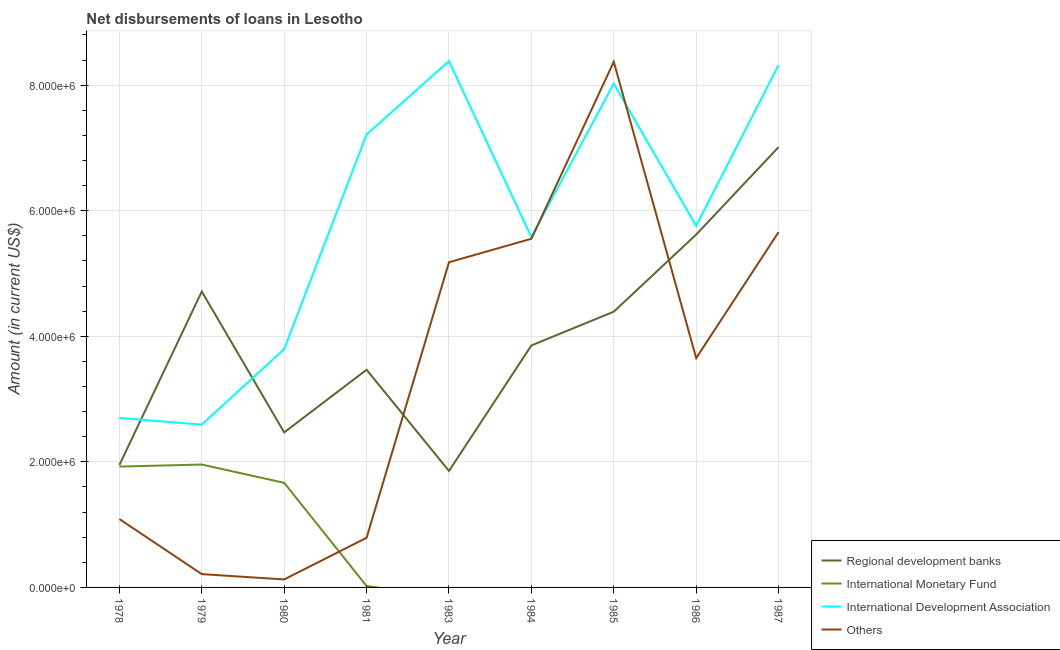What is the amount of loan disimbursed by other organisations in 1980?
Ensure brevity in your answer.  1.27e+05. Across all years, what is the maximum amount of loan disimbursed by international development association?
Give a very brief answer. 8.38e+06. Across all years, what is the minimum amount of loan disimbursed by regional development banks?
Give a very brief answer. 1.86e+06. In which year was the amount of loan disimbursed by regional development banks maximum?
Keep it short and to the point. 1987. What is the total amount of loan disimbursed by international monetary fund in the graph?
Give a very brief answer. 5.57e+06. What is the difference between the amount of loan disimbursed by other organisations in 1978 and that in 1984?
Your answer should be very brief. -4.46e+06. What is the difference between the amount of loan disimbursed by regional development banks in 1981 and the amount of loan disimbursed by other organisations in 1980?
Offer a terse response. 3.34e+06. What is the average amount of loan disimbursed by other organisations per year?
Provide a succinct answer. 3.40e+06. In the year 1980, what is the difference between the amount of loan disimbursed by international development association and amount of loan disimbursed by international monetary fund?
Provide a short and direct response. 2.13e+06. What is the ratio of the amount of loan disimbursed by international development association in 1979 to that in 1984?
Offer a very short reply. 0.46. Is the amount of loan disimbursed by regional development banks in 1979 less than that in 1986?
Provide a succinct answer. Yes. Is the difference between the amount of loan disimbursed by regional development banks in 1978 and 1979 greater than the difference between the amount of loan disimbursed by international monetary fund in 1978 and 1979?
Provide a short and direct response. No. What is the difference between the highest and the second highest amount of loan disimbursed by international development association?
Make the answer very short. 6.30e+04. What is the difference between the highest and the lowest amount of loan disimbursed by international monetary fund?
Make the answer very short. 1.96e+06. Is it the case that in every year, the sum of the amount of loan disimbursed by other organisations and amount of loan disimbursed by international development association is greater than the sum of amount of loan disimbursed by international monetary fund and amount of loan disimbursed by regional development banks?
Your response must be concise. No. Is it the case that in every year, the sum of the amount of loan disimbursed by regional development banks and amount of loan disimbursed by international monetary fund is greater than the amount of loan disimbursed by international development association?
Your response must be concise. No. Are the values on the major ticks of Y-axis written in scientific E-notation?
Offer a very short reply. Yes. Does the graph contain grids?
Your answer should be very brief. Yes. Where does the legend appear in the graph?
Make the answer very short. Bottom right. How many legend labels are there?
Your answer should be very brief. 4. How are the legend labels stacked?
Provide a short and direct response. Vertical. What is the title of the graph?
Keep it short and to the point. Net disbursements of loans in Lesotho. What is the label or title of the Y-axis?
Make the answer very short. Amount (in current US$). What is the Amount (in current US$) in Regional development banks in 1978?
Provide a succinct answer. 1.95e+06. What is the Amount (in current US$) of International Monetary Fund in 1978?
Provide a succinct answer. 1.92e+06. What is the Amount (in current US$) of International Development Association in 1978?
Offer a terse response. 2.70e+06. What is the Amount (in current US$) of Others in 1978?
Give a very brief answer. 1.09e+06. What is the Amount (in current US$) in Regional development banks in 1979?
Your response must be concise. 4.71e+06. What is the Amount (in current US$) in International Monetary Fund in 1979?
Your answer should be very brief. 1.96e+06. What is the Amount (in current US$) of International Development Association in 1979?
Provide a succinct answer. 2.59e+06. What is the Amount (in current US$) of Others in 1979?
Give a very brief answer. 2.12e+05. What is the Amount (in current US$) in Regional development banks in 1980?
Provide a short and direct response. 2.47e+06. What is the Amount (in current US$) in International Monetary Fund in 1980?
Your answer should be very brief. 1.67e+06. What is the Amount (in current US$) in International Development Association in 1980?
Your response must be concise. 3.80e+06. What is the Amount (in current US$) in Others in 1980?
Your response must be concise. 1.27e+05. What is the Amount (in current US$) of Regional development banks in 1981?
Provide a succinct answer. 3.47e+06. What is the Amount (in current US$) of International Monetary Fund in 1981?
Provide a succinct answer. 2.20e+04. What is the Amount (in current US$) in International Development Association in 1981?
Your response must be concise. 7.21e+06. What is the Amount (in current US$) in Others in 1981?
Keep it short and to the point. 7.91e+05. What is the Amount (in current US$) in Regional development banks in 1983?
Ensure brevity in your answer.  1.86e+06. What is the Amount (in current US$) in International Development Association in 1983?
Your answer should be very brief. 8.38e+06. What is the Amount (in current US$) in Others in 1983?
Offer a terse response. 5.18e+06. What is the Amount (in current US$) in Regional development banks in 1984?
Your answer should be very brief. 3.85e+06. What is the Amount (in current US$) of International Monetary Fund in 1984?
Your answer should be very brief. 0. What is the Amount (in current US$) of International Development Association in 1984?
Keep it short and to the point. 5.58e+06. What is the Amount (in current US$) in Others in 1984?
Offer a terse response. 5.55e+06. What is the Amount (in current US$) of Regional development banks in 1985?
Provide a succinct answer. 4.39e+06. What is the Amount (in current US$) in International Monetary Fund in 1985?
Offer a terse response. 0. What is the Amount (in current US$) of International Development Association in 1985?
Provide a succinct answer. 8.02e+06. What is the Amount (in current US$) of Others in 1985?
Your response must be concise. 8.37e+06. What is the Amount (in current US$) of Regional development banks in 1986?
Your answer should be compact. 5.62e+06. What is the Amount (in current US$) in International Development Association in 1986?
Keep it short and to the point. 5.76e+06. What is the Amount (in current US$) in Others in 1986?
Your answer should be very brief. 3.65e+06. What is the Amount (in current US$) of Regional development banks in 1987?
Make the answer very short. 7.01e+06. What is the Amount (in current US$) of International Development Association in 1987?
Offer a very short reply. 8.32e+06. What is the Amount (in current US$) of Others in 1987?
Give a very brief answer. 5.66e+06. Across all years, what is the maximum Amount (in current US$) of Regional development banks?
Offer a terse response. 7.01e+06. Across all years, what is the maximum Amount (in current US$) in International Monetary Fund?
Keep it short and to the point. 1.96e+06. Across all years, what is the maximum Amount (in current US$) of International Development Association?
Give a very brief answer. 8.38e+06. Across all years, what is the maximum Amount (in current US$) in Others?
Your answer should be compact. 8.37e+06. Across all years, what is the minimum Amount (in current US$) in Regional development banks?
Your answer should be very brief. 1.86e+06. Across all years, what is the minimum Amount (in current US$) in International Development Association?
Make the answer very short. 2.59e+06. Across all years, what is the minimum Amount (in current US$) of Others?
Keep it short and to the point. 1.27e+05. What is the total Amount (in current US$) of Regional development banks in the graph?
Make the answer very short. 3.53e+07. What is the total Amount (in current US$) of International Monetary Fund in the graph?
Give a very brief answer. 5.57e+06. What is the total Amount (in current US$) of International Development Association in the graph?
Your answer should be compact. 5.24e+07. What is the total Amount (in current US$) of Others in the graph?
Offer a very short reply. 3.06e+07. What is the difference between the Amount (in current US$) of Regional development banks in 1978 and that in 1979?
Offer a terse response. -2.76e+06. What is the difference between the Amount (in current US$) in International Monetary Fund in 1978 and that in 1979?
Ensure brevity in your answer.  -3.20e+04. What is the difference between the Amount (in current US$) in International Development Association in 1978 and that in 1979?
Offer a very short reply. 1.06e+05. What is the difference between the Amount (in current US$) of Others in 1978 and that in 1979?
Ensure brevity in your answer.  8.77e+05. What is the difference between the Amount (in current US$) in Regional development banks in 1978 and that in 1980?
Give a very brief answer. -5.19e+05. What is the difference between the Amount (in current US$) of International Monetary Fund in 1978 and that in 1980?
Give a very brief answer. 2.59e+05. What is the difference between the Amount (in current US$) in International Development Association in 1978 and that in 1980?
Keep it short and to the point. -1.10e+06. What is the difference between the Amount (in current US$) of Others in 1978 and that in 1980?
Give a very brief answer. 9.62e+05. What is the difference between the Amount (in current US$) of Regional development banks in 1978 and that in 1981?
Your answer should be very brief. -1.52e+06. What is the difference between the Amount (in current US$) in International Monetary Fund in 1978 and that in 1981?
Your answer should be very brief. 1.90e+06. What is the difference between the Amount (in current US$) of International Development Association in 1978 and that in 1981?
Your answer should be very brief. -4.51e+06. What is the difference between the Amount (in current US$) in Others in 1978 and that in 1981?
Make the answer very short. 2.98e+05. What is the difference between the Amount (in current US$) in Regional development banks in 1978 and that in 1983?
Your response must be concise. 9.50e+04. What is the difference between the Amount (in current US$) of International Development Association in 1978 and that in 1983?
Keep it short and to the point. -5.68e+06. What is the difference between the Amount (in current US$) in Others in 1978 and that in 1983?
Keep it short and to the point. -4.09e+06. What is the difference between the Amount (in current US$) in Regional development banks in 1978 and that in 1984?
Provide a succinct answer. -1.90e+06. What is the difference between the Amount (in current US$) of International Development Association in 1978 and that in 1984?
Make the answer very short. -2.88e+06. What is the difference between the Amount (in current US$) in Others in 1978 and that in 1984?
Provide a succinct answer. -4.46e+06. What is the difference between the Amount (in current US$) of Regional development banks in 1978 and that in 1985?
Your answer should be compact. -2.44e+06. What is the difference between the Amount (in current US$) in International Development Association in 1978 and that in 1985?
Ensure brevity in your answer.  -5.32e+06. What is the difference between the Amount (in current US$) in Others in 1978 and that in 1985?
Provide a short and direct response. -7.28e+06. What is the difference between the Amount (in current US$) of Regional development banks in 1978 and that in 1986?
Ensure brevity in your answer.  -3.67e+06. What is the difference between the Amount (in current US$) in International Development Association in 1978 and that in 1986?
Offer a terse response. -3.06e+06. What is the difference between the Amount (in current US$) in Others in 1978 and that in 1986?
Provide a short and direct response. -2.56e+06. What is the difference between the Amount (in current US$) in Regional development banks in 1978 and that in 1987?
Provide a succinct answer. -5.06e+06. What is the difference between the Amount (in current US$) in International Development Association in 1978 and that in 1987?
Offer a terse response. -5.62e+06. What is the difference between the Amount (in current US$) in Others in 1978 and that in 1987?
Offer a terse response. -4.57e+06. What is the difference between the Amount (in current US$) of Regional development banks in 1979 and that in 1980?
Your answer should be compact. 2.24e+06. What is the difference between the Amount (in current US$) of International Monetary Fund in 1979 and that in 1980?
Make the answer very short. 2.91e+05. What is the difference between the Amount (in current US$) in International Development Association in 1979 and that in 1980?
Provide a succinct answer. -1.20e+06. What is the difference between the Amount (in current US$) of Others in 1979 and that in 1980?
Make the answer very short. 8.50e+04. What is the difference between the Amount (in current US$) of Regional development banks in 1979 and that in 1981?
Your answer should be very brief. 1.25e+06. What is the difference between the Amount (in current US$) in International Monetary Fund in 1979 and that in 1981?
Provide a succinct answer. 1.94e+06. What is the difference between the Amount (in current US$) of International Development Association in 1979 and that in 1981?
Your response must be concise. -4.62e+06. What is the difference between the Amount (in current US$) of Others in 1979 and that in 1981?
Your response must be concise. -5.79e+05. What is the difference between the Amount (in current US$) in Regional development banks in 1979 and that in 1983?
Your answer should be very brief. 2.86e+06. What is the difference between the Amount (in current US$) in International Development Association in 1979 and that in 1983?
Offer a very short reply. -5.79e+06. What is the difference between the Amount (in current US$) in Others in 1979 and that in 1983?
Your answer should be very brief. -4.97e+06. What is the difference between the Amount (in current US$) in Regional development banks in 1979 and that in 1984?
Give a very brief answer. 8.59e+05. What is the difference between the Amount (in current US$) of International Development Association in 1979 and that in 1984?
Give a very brief answer. -2.99e+06. What is the difference between the Amount (in current US$) in Others in 1979 and that in 1984?
Offer a terse response. -5.34e+06. What is the difference between the Amount (in current US$) of Regional development banks in 1979 and that in 1985?
Ensure brevity in your answer.  3.21e+05. What is the difference between the Amount (in current US$) of International Development Association in 1979 and that in 1985?
Give a very brief answer. -5.43e+06. What is the difference between the Amount (in current US$) of Others in 1979 and that in 1985?
Offer a terse response. -8.16e+06. What is the difference between the Amount (in current US$) of Regional development banks in 1979 and that in 1986?
Offer a very short reply. -9.07e+05. What is the difference between the Amount (in current US$) of International Development Association in 1979 and that in 1986?
Ensure brevity in your answer.  -3.17e+06. What is the difference between the Amount (in current US$) of Others in 1979 and that in 1986?
Keep it short and to the point. -3.44e+06. What is the difference between the Amount (in current US$) in Regional development banks in 1979 and that in 1987?
Offer a terse response. -2.30e+06. What is the difference between the Amount (in current US$) in International Development Association in 1979 and that in 1987?
Your answer should be compact. -5.73e+06. What is the difference between the Amount (in current US$) of Others in 1979 and that in 1987?
Give a very brief answer. -5.45e+06. What is the difference between the Amount (in current US$) of Regional development banks in 1980 and that in 1981?
Keep it short and to the point. -9.98e+05. What is the difference between the Amount (in current US$) in International Monetary Fund in 1980 and that in 1981?
Your answer should be very brief. 1.64e+06. What is the difference between the Amount (in current US$) in International Development Association in 1980 and that in 1981?
Provide a short and direct response. -3.42e+06. What is the difference between the Amount (in current US$) in Others in 1980 and that in 1981?
Give a very brief answer. -6.64e+05. What is the difference between the Amount (in current US$) in Regional development banks in 1980 and that in 1983?
Your answer should be very brief. 6.14e+05. What is the difference between the Amount (in current US$) in International Development Association in 1980 and that in 1983?
Make the answer very short. -4.59e+06. What is the difference between the Amount (in current US$) in Others in 1980 and that in 1983?
Keep it short and to the point. -5.05e+06. What is the difference between the Amount (in current US$) in Regional development banks in 1980 and that in 1984?
Offer a very short reply. -1.38e+06. What is the difference between the Amount (in current US$) of International Development Association in 1980 and that in 1984?
Provide a short and direct response. -1.79e+06. What is the difference between the Amount (in current US$) of Others in 1980 and that in 1984?
Keep it short and to the point. -5.43e+06. What is the difference between the Amount (in current US$) of Regional development banks in 1980 and that in 1985?
Your answer should be compact. -1.92e+06. What is the difference between the Amount (in current US$) in International Development Association in 1980 and that in 1985?
Your response must be concise. -4.23e+06. What is the difference between the Amount (in current US$) of Others in 1980 and that in 1985?
Your answer should be compact. -8.24e+06. What is the difference between the Amount (in current US$) of Regional development banks in 1980 and that in 1986?
Provide a succinct answer. -3.15e+06. What is the difference between the Amount (in current US$) of International Development Association in 1980 and that in 1986?
Provide a succinct answer. -1.96e+06. What is the difference between the Amount (in current US$) of Others in 1980 and that in 1986?
Ensure brevity in your answer.  -3.52e+06. What is the difference between the Amount (in current US$) in Regional development banks in 1980 and that in 1987?
Your answer should be compact. -4.54e+06. What is the difference between the Amount (in current US$) of International Development Association in 1980 and that in 1987?
Offer a very short reply. -4.52e+06. What is the difference between the Amount (in current US$) in Others in 1980 and that in 1987?
Provide a short and direct response. -5.53e+06. What is the difference between the Amount (in current US$) in Regional development banks in 1981 and that in 1983?
Your response must be concise. 1.61e+06. What is the difference between the Amount (in current US$) in International Development Association in 1981 and that in 1983?
Your answer should be compact. -1.17e+06. What is the difference between the Amount (in current US$) in Others in 1981 and that in 1983?
Give a very brief answer. -4.39e+06. What is the difference between the Amount (in current US$) of Regional development banks in 1981 and that in 1984?
Ensure brevity in your answer.  -3.87e+05. What is the difference between the Amount (in current US$) of International Development Association in 1981 and that in 1984?
Offer a very short reply. 1.63e+06. What is the difference between the Amount (in current US$) of Others in 1981 and that in 1984?
Your answer should be compact. -4.76e+06. What is the difference between the Amount (in current US$) in Regional development banks in 1981 and that in 1985?
Your answer should be compact. -9.25e+05. What is the difference between the Amount (in current US$) in International Development Association in 1981 and that in 1985?
Offer a very short reply. -8.11e+05. What is the difference between the Amount (in current US$) of Others in 1981 and that in 1985?
Ensure brevity in your answer.  -7.58e+06. What is the difference between the Amount (in current US$) of Regional development banks in 1981 and that in 1986?
Your answer should be compact. -2.15e+06. What is the difference between the Amount (in current US$) in International Development Association in 1981 and that in 1986?
Your response must be concise. 1.45e+06. What is the difference between the Amount (in current US$) of Others in 1981 and that in 1986?
Your response must be concise. -2.86e+06. What is the difference between the Amount (in current US$) of Regional development banks in 1981 and that in 1987?
Ensure brevity in your answer.  -3.55e+06. What is the difference between the Amount (in current US$) of International Development Association in 1981 and that in 1987?
Provide a short and direct response. -1.11e+06. What is the difference between the Amount (in current US$) in Others in 1981 and that in 1987?
Make the answer very short. -4.87e+06. What is the difference between the Amount (in current US$) in Regional development banks in 1983 and that in 1984?
Give a very brief answer. -2.00e+06. What is the difference between the Amount (in current US$) of International Development Association in 1983 and that in 1984?
Offer a terse response. 2.80e+06. What is the difference between the Amount (in current US$) in Others in 1983 and that in 1984?
Offer a terse response. -3.74e+05. What is the difference between the Amount (in current US$) in Regional development banks in 1983 and that in 1985?
Ensure brevity in your answer.  -2.54e+06. What is the difference between the Amount (in current US$) of International Development Association in 1983 and that in 1985?
Your answer should be compact. 3.58e+05. What is the difference between the Amount (in current US$) of Others in 1983 and that in 1985?
Offer a terse response. -3.19e+06. What is the difference between the Amount (in current US$) of Regional development banks in 1983 and that in 1986?
Provide a succinct answer. -3.76e+06. What is the difference between the Amount (in current US$) of International Development Association in 1983 and that in 1986?
Offer a very short reply. 2.62e+06. What is the difference between the Amount (in current US$) of Others in 1983 and that in 1986?
Your answer should be very brief. 1.53e+06. What is the difference between the Amount (in current US$) in Regional development banks in 1983 and that in 1987?
Your response must be concise. -5.16e+06. What is the difference between the Amount (in current US$) of International Development Association in 1983 and that in 1987?
Offer a terse response. 6.30e+04. What is the difference between the Amount (in current US$) of Others in 1983 and that in 1987?
Keep it short and to the point. -4.80e+05. What is the difference between the Amount (in current US$) in Regional development banks in 1984 and that in 1985?
Make the answer very short. -5.38e+05. What is the difference between the Amount (in current US$) in International Development Association in 1984 and that in 1985?
Your answer should be compact. -2.44e+06. What is the difference between the Amount (in current US$) of Others in 1984 and that in 1985?
Make the answer very short. -2.82e+06. What is the difference between the Amount (in current US$) in Regional development banks in 1984 and that in 1986?
Your answer should be compact. -1.77e+06. What is the difference between the Amount (in current US$) in International Development Association in 1984 and that in 1986?
Give a very brief answer. -1.78e+05. What is the difference between the Amount (in current US$) of Others in 1984 and that in 1986?
Your response must be concise. 1.90e+06. What is the difference between the Amount (in current US$) of Regional development banks in 1984 and that in 1987?
Your answer should be compact. -3.16e+06. What is the difference between the Amount (in current US$) in International Development Association in 1984 and that in 1987?
Your answer should be compact. -2.74e+06. What is the difference between the Amount (in current US$) of Others in 1984 and that in 1987?
Offer a very short reply. -1.06e+05. What is the difference between the Amount (in current US$) in Regional development banks in 1985 and that in 1986?
Keep it short and to the point. -1.23e+06. What is the difference between the Amount (in current US$) of International Development Association in 1985 and that in 1986?
Provide a succinct answer. 2.26e+06. What is the difference between the Amount (in current US$) in Others in 1985 and that in 1986?
Offer a terse response. 4.72e+06. What is the difference between the Amount (in current US$) in Regional development banks in 1985 and that in 1987?
Provide a succinct answer. -2.62e+06. What is the difference between the Amount (in current US$) in International Development Association in 1985 and that in 1987?
Give a very brief answer. -2.95e+05. What is the difference between the Amount (in current US$) in Others in 1985 and that in 1987?
Your answer should be very brief. 2.71e+06. What is the difference between the Amount (in current US$) of Regional development banks in 1986 and that in 1987?
Provide a succinct answer. -1.39e+06. What is the difference between the Amount (in current US$) in International Development Association in 1986 and that in 1987?
Give a very brief answer. -2.56e+06. What is the difference between the Amount (in current US$) in Others in 1986 and that in 1987?
Ensure brevity in your answer.  -2.01e+06. What is the difference between the Amount (in current US$) in Regional development banks in 1978 and the Amount (in current US$) in International Monetary Fund in 1979?
Ensure brevity in your answer.  -7000. What is the difference between the Amount (in current US$) of Regional development banks in 1978 and the Amount (in current US$) of International Development Association in 1979?
Your answer should be compact. -6.43e+05. What is the difference between the Amount (in current US$) of Regional development banks in 1978 and the Amount (in current US$) of Others in 1979?
Provide a succinct answer. 1.74e+06. What is the difference between the Amount (in current US$) in International Monetary Fund in 1978 and the Amount (in current US$) in International Development Association in 1979?
Make the answer very short. -6.68e+05. What is the difference between the Amount (in current US$) of International Monetary Fund in 1978 and the Amount (in current US$) of Others in 1979?
Provide a short and direct response. 1.71e+06. What is the difference between the Amount (in current US$) of International Development Association in 1978 and the Amount (in current US$) of Others in 1979?
Make the answer very short. 2.49e+06. What is the difference between the Amount (in current US$) of Regional development banks in 1978 and the Amount (in current US$) of International Monetary Fund in 1980?
Keep it short and to the point. 2.84e+05. What is the difference between the Amount (in current US$) in Regional development banks in 1978 and the Amount (in current US$) in International Development Association in 1980?
Make the answer very short. -1.84e+06. What is the difference between the Amount (in current US$) in Regional development banks in 1978 and the Amount (in current US$) in Others in 1980?
Your response must be concise. 1.82e+06. What is the difference between the Amount (in current US$) in International Monetary Fund in 1978 and the Amount (in current US$) in International Development Association in 1980?
Provide a short and direct response. -1.87e+06. What is the difference between the Amount (in current US$) of International Monetary Fund in 1978 and the Amount (in current US$) of Others in 1980?
Provide a short and direct response. 1.80e+06. What is the difference between the Amount (in current US$) in International Development Association in 1978 and the Amount (in current US$) in Others in 1980?
Offer a very short reply. 2.57e+06. What is the difference between the Amount (in current US$) in Regional development banks in 1978 and the Amount (in current US$) in International Monetary Fund in 1981?
Your answer should be compact. 1.93e+06. What is the difference between the Amount (in current US$) of Regional development banks in 1978 and the Amount (in current US$) of International Development Association in 1981?
Offer a terse response. -5.26e+06. What is the difference between the Amount (in current US$) in Regional development banks in 1978 and the Amount (in current US$) in Others in 1981?
Make the answer very short. 1.16e+06. What is the difference between the Amount (in current US$) of International Monetary Fund in 1978 and the Amount (in current US$) of International Development Association in 1981?
Give a very brief answer. -5.29e+06. What is the difference between the Amount (in current US$) of International Monetary Fund in 1978 and the Amount (in current US$) of Others in 1981?
Keep it short and to the point. 1.13e+06. What is the difference between the Amount (in current US$) in International Development Association in 1978 and the Amount (in current US$) in Others in 1981?
Offer a very short reply. 1.91e+06. What is the difference between the Amount (in current US$) in Regional development banks in 1978 and the Amount (in current US$) in International Development Association in 1983?
Your answer should be very brief. -6.43e+06. What is the difference between the Amount (in current US$) in Regional development banks in 1978 and the Amount (in current US$) in Others in 1983?
Keep it short and to the point. -3.23e+06. What is the difference between the Amount (in current US$) of International Monetary Fund in 1978 and the Amount (in current US$) of International Development Association in 1983?
Provide a short and direct response. -6.46e+06. What is the difference between the Amount (in current US$) in International Monetary Fund in 1978 and the Amount (in current US$) in Others in 1983?
Offer a terse response. -3.25e+06. What is the difference between the Amount (in current US$) of International Development Association in 1978 and the Amount (in current US$) of Others in 1983?
Your answer should be very brief. -2.48e+06. What is the difference between the Amount (in current US$) in Regional development banks in 1978 and the Amount (in current US$) in International Development Association in 1984?
Provide a succinct answer. -3.63e+06. What is the difference between the Amount (in current US$) of Regional development banks in 1978 and the Amount (in current US$) of Others in 1984?
Offer a terse response. -3.60e+06. What is the difference between the Amount (in current US$) in International Monetary Fund in 1978 and the Amount (in current US$) in International Development Association in 1984?
Your response must be concise. -3.66e+06. What is the difference between the Amount (in current US$) of International Monetary Fund in 1978 and the Amount (in current US$) of Others in 1984?
Offer a very short reply. -3.63e+06. What is the difference between the Amount (in current US$) of International Development Association in 1978 and the Amount (in current US$) of Others in 1984?
Offer a very short reply. -2.85e+06. What is the difference between the Amount (in current US$) in Regional development banks in 1978 and the Amount (in current US$) in International Development Association in 1985?
Make the answer very short. -6.07e+06. What is the difference between the Amount (in current US$) in Regional development banks in 1978 and the Amount (in current US$) in Others in 1985?
Keep it short and to the point. -6.42e+06. What is the difference between the Amount (in current US$) of International Monetary Fund in 1978 and the Amount (in current US$) of International Development Association in 1985?
Provide a succinct answer. -6.10e+06. What is the difference between the Amount (in current US$) of International Monetary Fund in 1978 and the Amount (in current US$) of Others in 1985?
Offer a very short reply. -6.45e+06. What is the difference between the Amount (in current US$) in International Development Association in 1978 and the Amount (in current US$) in Others in 1985?
Provide a short and direct response. -5.67e+06. What is the difference between the Amount (in current US$) in Regional development banks in 1978 and the Amount (in current US$) in International Development Association in 1986?
Provide a succinct answer. -3.81e+06. What is the difference between the Amount (in current US$) of Regional development banks in 1978 and the Amount (in current US$) of Others in 1986?
Provide a short and direct response. -1.70e+06. What is the difference between the Amount (in current US$) in International Monetary Fund in 1978 and the Amount (in current US$) in International Development Association in 1986?
Keep it short and to the point. -3.83e+06. What is the difference between the Amount (in current US$) in International Monetary Fund in 1978 and the Amount (in current US$) in Others in 1986?
Give a very brief answer. -1.73e+06. What is the difference between the Amount (in current US$) of International Development Association in 1978 and the Amount (in current US$) of Others in 1986?
Offer a terse response. -9.53e+05. What is the difference between the Amount (in current US$) of Regional development banks in 1978 and the Amount (in current US$) of International Development Association in 1987?
Provide a short and direct response. -6.37e+06. What is the difference between the Amount (in current US$) in Regional development banks in 1978 and the Amount (in current US$) in Others in 1987?
Provide a succinct answer. -3.71e+06. What is the difference between the Amount (in current US$) of International Monetary Fund in 1978 and the Amount (in current US$) of International Development Association in 1987?
Ensure brevity in your answer.  -6.39e+06. What is the difference between the Amount (in current US$) in International Monetary Fund in 1978 and the Amount (in current US$) in Others in 1987?
Offer a very short reply. -3.73e+06. What is the difference between the Amount (in current US$) in International Development Association in 1978 and the Amount (in current US$) in Others in 1987?
Make the answer very short. -2.96e+06. What is the difference between the Amount (in current US$) of Regional development banks in 1979 and the Amount (in current US$) of International Monetary Fund in 1980?
Keep it short and to the point. 3.05e+06. What is the difference between the Amount (in current US$) in Regional development banks in 1979 and the Amount (in current US$) in International Development Association in 1980?
Provide a short and direct response. 9.18e+05. What is the difference between the Amount (in current US$) in Regional development banks in 1979 and the Amount (in current US$) in Others in 1980?
Offer a very short reply. 4.59e+06. What is the difference between the Amount (in current US$) of International Monetary Fund in 1979 and the Amount (in current US$) of International Development Association in 1980?
Make the answer very short. -1.84e+06. What is the difference between the Amount (in current US$) in International Monetary Fund in 1979 and the Amount (in current US$) in Others in 1980?
Provide a succinct answer. 1.83e+06. What is the difference between the Amount (in current US$) in International Development Association in 1979 and the Amount (in current US$) in Others in 1980?
Keep it short and to the point. 2.47e+06. What is the difference between the Amount (in current US$) of Regional development banks in 1979 and the Amount (in current US$) of International Monetary Fund in 1981?
Offer a very short reply. 4.69e+06. What is the difference between the Amount (in current US$) in Regional development banks in 1979 and the Amount (in current US$) in International Development Association in 1981?
Ensure brevity in your answer.  -2.50e+06. What is the difference between the Amount (in current US$) in Regional development banks in 1979 and the Amount (in current US$) in Others in 1981?
Your answer should be very brief. 3.92e+06. What is the difference between the Amount (in current US$) in International Monetary Fund in 1979 and the Amount (in current US$) in International Development Association in 1981?
Your answer should be very brief. -5.26e+06. What is the difference between the Amount (in current US$) of International Monetary Fund in 1979 and the Amount (in current US$) of Others in 1981?
Ensure brevity in your answer.  1.17e+06. What is the difference between the Amount (in current US$) in International Development Association in 1979 and the Amount (in current US$) in Others in 1981?
Make the answer very short. 1.80e+06. What is the difference between the Amount (in current US$) of Regional development banks in 1979 and the Amount (in current US$) of International Development Association in 1983?
Provide a succinct answer. -3.67e+06. What is the difference between the Amount (in current US$) in Regional development banks in 1979 and the Amount (in current US$) in Others in 1983?
Provide a succinct answer. -4.66e+05. What is the difference between the Amount (in current US$) of International Monetary Fund in 1979 and the Amount (in current US$) of International Development Association in 1983?
Offer a terse response. -6.42e+06. What is the difference between the Amount (in current US$) of International Monetary Fund in 1979 and the Amount (in current US$) of Others in 1983?
Give a very brief answer. -3.22e+06. What is the difference between the Amount (in current US$) of International Development Association in 1979 and the Amount (in current US$) of Others in 1983?
Keep it short and to the point. -2.59e+06. What is the difference between the Amount (in current US$) in Regional development banks in 1979 and the Amount (in current US$) in International Development Association in 1984?
Give a very brief answer. -8.68e+05. What is the difference between the Amount (in current US$) in Regional development banks in 1979 and the Amount (in current US$) in Others in 1984?
Keep it short and to the point. -8.40e+05. What is the difference between the Amount (in current US$) in International Monetary Fund in 1979 and the Amount (in current US$) in International Development Association in 1984?
Your response must be concise. -3.62e+06. What is the difference between the Amount (in current US$) of International Monetary Fund in 1979 and the Amount (in current US$) of Others in 1984?
Ensure brevity in your answer.  -3.60e+06. What is the difference between the Amount (in current US$) in International Development Association in 1979 and the Amount (in current US$) in Others in 1984?
Provide a short and direct response. -2.96e+06. What is the difference between the Amount (in current US$) in Regional development banks in 1979 and the Amount (in current US$) in International Development Association in 1985?
Your response must be concise. -3.31e+06. What is the difference between the Amount (in current US$) of Regional development banks in 1979 and the Amount (in current US$) of Others in 1985?
Provide a short and direct response. -3.66e+06. What is the difference between the Amount (in current US$) in International Monetary Fund in 1979 and the Amount (in current US$) in International Development Association in 1985?
Provide a succinct answer. -6.07e+06. What is the difference between the Amount (in current US$) in International Monetary Fund in 1979 and the Amount (in current US$) in Others in 1985?
Your answer should be compact. -6.42e+06. What is the difference between the Amount (in current US$) of International Development Association in 1979 and the Amount (in current US$) of Others in 1985?
Keep it short and to the point. -5.78e+06. What is the difference between the Amount (in current US$) in Regional development banks in 1979 and the Amount (in current US$) in International Development Association in 1986?
Your answer should be compact. -1.05e+06. What is the difference between the Amount (in current US$) in Regional development banks in 1979 and the Amount (in current US$) in Others in 1986?
Your answer should be very brief. 1.06e+06. What is the difference between the Amount (in current US$) in International Monetary Fund in 1979 and the Amount (in current US$) in International Development Association in 1986?
Give a very brief answer. -3.80e+06. What is the difference between the Amount (in current US$) in International Monetary Fund in 1979 and the Amount (in current US$) in Others in 1986?
Make the answer very short. -1.70e+06. What is the difference between the Amount (in current US$) of International Development Association in 1979 and the Amount (in current US$) of Others in 1986?
Your answer should be compact. -1.06e+06. What is the difference between the Amount (in current US$) in Regional development banks in 1979 and the Amount (in current US$) in International Development Association in 1987?
Provide a succinct answer. -3.61e+06. What is the difference between the Amount (in current US$) in Regional development banks in 1979 and the Amount (in current US$) in Others in 1987?
Provide a short and direct response. -9.46e+05. What is the difference between the Amount (in current US$) of International Monetary Fund in 1979 and the Amount (in current US$) of International Development Association in 1987?
Keep it short and to the point. -6.36e+06. What is the difference between the Amount (in current US$) of International Monetary Fund in 1979 and the Amount (in current US$) of Others in 1987?
Provide a short and direct response. -3.70e+06. What is the difference between the Amount (in current US$) of International Development Association in 1979 and the Amount (in current US$) of Others in 1987?
Your answer should be very brief. -3.07e+06. What is the difference between the Amount (in current US$) of Regional development banks in 1980 and the Amount (in current US$) of International Monetary Fund in 1981?
Your response must be concise. 2.45e+06. What is the difference between the Amount (in current US$) in Regional development banks in 1980 and the Amount (in current US$) in International Development Association in 1981?
Keep it short and to the point. -4.74e+06. What is the difference between the Amount (in current US$) in Regional development banks in 1980 and the Amount (in current US$) in Others in 1981?
Offer a very short reply. 1.68e+06. What is the difference between the Amount (in current US$) of International Monetary Fund in 1980 and the Amount (in current US$) of International Development Association in 1981?
Your response must be concise. -5.55e+06. What is the difference between the Amount (in current US$) in International Monetary Fund in 1980 and the Amount (in current US$) in Others in 1981?
Ensure brevity in your answer.  8.75e+05. What is the difference between the Amount (in current US$) in International Development Association in 1980 and the Amount (in current US$) in Others in 1981?
Keep it short and to the point. 3.00e+06. What is the difference between the Amount (in current US$) in Regional development banks in 1980 and the Amount (in current US$) in International Development Association in 1983?
Provide a short and direct response. -5.91e+06. What is the difference between the Amount (in current US$) in Regional development banks in 1980 and the Amount (in current US$) in Others in 1983?
Your response must be concise. -2.71e+06. What is the difference between the Amount (in current US$) of International Monetary Fund in 1980 and the Amount (in current US$) of International Development Association in 1983?
Provide a short and direct response. -6.72e+06. What is the difference between the Amount (in current US$) in International Monetary Fund in 1980 and the Amount (in current US$) in Others in 1983?
Your answer should be very brief. -3.51e+06. What is the difference between the Amount (in current US$) in International Development Association in 1980 and the Amount (in current US$) in Others in 1983?
Give a very brief answer. -1.38e+06. What is the difference between the Amount (in current US$) of Regional development banks in 1980 and the Amount (in current US$) of International Development Association in 1984?
Your answer should be compact. -3.11e+06. What is the difference between the Amount (in current US$) of Regional development banks in 1980 and the Amount (in current US$) of Others in 1984?
Offer a very short reply. -3.08e+06. What is the difference between the Amount (in current US$) of International Monetary Fund in 1980 and the Amount (in current US$) of International Development Association in 1984?
Provide a short and direct response. -3.92e+06. What is the difference between the Amount (in current US$) in International Monetary Fund in 1980 and the Amount (in current US$) in Others in 1984?
Your answer should be compact. -3.89e+06. What is the difference between the Amount (in current US$) of International Development Association in 1980 and the Amount (in current US$) of Others in 1984?
Offer a very short reply. -1.76e+06. What is the difference between the Amount (in current US$) in Regional development banks in 1980 and the Amount (in current US$) in International Development Association in 1985?
Make the answer very short. -5.56e+06. What is the difference between the Amount (in current US$) in Regional development banks in 1980 and the Amount (in current US$) in Others in 1985?
Your response must be concise. -5.90e+06. What is the difference between the Amount (in current US$) in International Monetary Fund in 1980 and the Amount (in current US$) in International Development Association in 1985?
Your response must be concise. -6.36e+06. What is the difference between the Amount (in current US$) in International Monetary Fund in 1980 and the Amount (in current US$) in Others in 1985?
Offer a terse response. -6.71e+06. What is the difference between the Amount (in current US$) in International Development Association in 1980 and the Amount (in current US$) in Others in 1985?
Offer a very short reply. -4.58e+06. What is the difference between the Amount (in current US$) in Regional development banks in 1980 and the Amount (in current US$) in International Development Association in 1986?
Provide a short and direct response. -3.29e+06. What is the difference between the Amount (in current US$) in Regional development banks in 1980 and the Amount (in current US$) in Others in 1986?
Offer a very short reply. -1.18e+06. What is the difference between the Amount (in current US$) of International Monetary Fund in 1980 and the Amount (in current US$) of International Development Association in 1986?
Your answer should be very brief. -4.09e+06. What is the difference between the Amount (in current US$) in International Monetary Fund in 1980 and the Amount (in current US$) in Others in 1986?
Ensure brevity in your answer.  -1.99e+06. What is the difference between the Amount (in current US$) of International Development Association in 1980 and the Amount (in current US$) of Others in 1986?
Give a very brief answer. 1.43e+05. What is the difference between the Amount (in current US$) of Regional development banks in 1980 and the Amount (in current US$) of International Development Association in 1987?
Offer a terse response. -5.85e+06. What is the difference between the Amount (in current US$) of Regional development banks in 1980 and the Amount (in current US$) of Others in 1987?
Ensure brevity in your answer.  -3.19e+06. What is the difference between the Amount (in current US$) in International Monetary Fund in 1980 and the Amount (in current US$) in International Development Association in 1987?
Your response must be concise. -6.65e+06. What is the difference between the Amount (in current US$) in International Monetary Fund in 1980 and the Amount (in current US$) in Others in 1987?
Your answer should be compact. -3.99e+06. What is the difference between the Amount (in current US$) of International Development Association in 1980 and the Amount (in current US$) of Others in 1987?
Provide a short and direct response. -1.86e+06. What is the difference between the Amount (in current US$) in Regional development banks in 1981 and the Amount (in current US$) in International Development Association in 1983?
Your answer should be compact. -4.92e+06. What is the difference between the Amount (in current US$) in Regional development banks in 1981 and the Amount (in current US$) in Others in 1983?
Ensure brevity in your answer.  -1.71e+06. What is the difference between the Amount (in current US$) of International Monetary Fund in 1981 and the Amount (in current US$) of International Development Association in 1983?
Your answer should be compact. -8.36e+06. What is the difference between the Amount (in current US$) in International Monetary Fund in 1981 and the Amount (in current US$) in Others in 1983?
Your answer should be very brief. -5.16e+06. What is the difference between the Amount (in current US$) in International Development Association in 1981 and the Amount (in current US$) in Others in 1983?
Ensure brevity in your answer.  2.03e+06. What is the difference between the Amount (in current US$) in Regional development banks in 1981 and the Amount (in current US$) in International Development Association in 1984?
Give a very brief answer. -2.11e+06. What is the difference between the Amount (in current US$) of Regional development banks in 1981 and the Amount (in current US$) of Others in 1984?
Give a very brief answer. -2.09e+06. What is the difference between the Amount (in current US$) in International Monetary Fund in 1981 and the Amount (in current US$) in International Development Association in 1984?
Provide a succinct answer. -5.56e+06. What is the difference between the Amount (in current US$) of International Monetary Fund in 1981 and the Amount (in current US$) of Others in 1984?
Provide a succinct answer. -5.53e+06. What is the difference between the Amount (in current US$) of International Development Association in 1981 and the Amount (in current US$) of Others in 1984?
Keep it short and to the point. 1.66e+06. What is the difference between the Amount (in current US$) of Regional development banks in 1981 and the Amount (in current US$) of International Development Association in 1985?
Make the answer very short. -4.56e+06. What is the difference between the Amount (in current US$) of Regional development banks in 1981 and the Amount (in current US$) of Others in 1985?
Provide a short and direct response. -4.90e+06. What is the difference between the Amount (in current US$) of International Monetary Fund in 1981 and the Amount (in current US$) of International Development Association in 1985?
Your answer should be compact. -8.00e+06. What is the difference between the Amount (in current US$) in International Monetary Fund in 1981 and the Amount (in current US$) in Others in 1985?
Provide a succinct answer. -8.35e+06. What is the difference between the Amount (in current US$) of International Development Association in 1981 and the Amount (in current US$) of Others in 1985?
Provide a succinct answer. -1.16e+06. What is the difference between the Amount (in current US$) of Regional development banks in 1981 and the Amount (in current US$) of International Development Association in 1986?
Provide a succinct answer. -2.29e+06. What is the difference between the Amount (in current US$) in Regional development banks in 1981 and the Amount (in current US$) in Others in 1986?
Keep it short and to the point. -1.85e+05. What is the difference between the Amount (in current US$) in International Monetary Fund in 1981 and the Amount (in current US$) in International Development Association in 1986?
Offer a very short reply. -5.74e+06. What is the difference between the Amount (in current US$) of International Monetary Fund in 1981 and the Amount (in current US$) of Others in 1986?
Ensure brevity in your answer.  -3.63e+06. What is the difference between the Amount (in current US$) in International Development Association in 1981 and the Amount (in current US$) in Others in 1986?
Keep it short and to the point. 3.56e+06. What is the difference between the Amount (in current US$) of Regional development banks in 1981 and the Amount (in current US$) of International Development Association in 1987?
Ensure brevity in your answer.  -4.85e+06. What is the difference between the Amount (in current US$) of Regional development banks in 1981 and the Amount (in current US$) of Others in 1987?
Ensure brevity in your answer.  -2.19e+06. What is the difference between the Amount (in current US$) in International Monetary Fund in 1981 and the Amount (in current US$) in International Development Association in 1987?
Your answer should be compact. -8.30e+06. What is the difference between the Amount (in current US$) of International Monetary Fund in 1981 and the Amount (in current US$) of Others in 1987?
Your answer should be compact. -5.64e+06. What is the difference between the Amount (in current US$) of International Development Association in 1981 and the Amount (in current US$) of Others in 1987?
Your response must be concise. 1.55e+06. What is the difference between the Amount (in current US$) in Regional development banks in 1983 and the Amount (in current US$) in International Development Association in 1984?
Your answer should be very brief. -3.73e+06. What is the difference between the Amount (in current US$) in Regional development banks in 1983 and the Amount (in current US$) in Others in 1984?
Your answer should be compact. -3.70e+06. What is the difference between the Amount (in current US$) in International Development Association in 1983 and the Amount (in current US$) in Others in 1984?
Your answer should be very brief. 2.83e+06. What is the difference between the Amount (in current US$) of Regional development banks in 1983 and the Amount (in current US$) of International Development Association in 1985?
Your answer should be very brief. -6.17e+06. What is the difference between the Amount (in current US$) in Regional development banks in 1983 and the Amount (in current US$) in Others in 1985?
Offer a very short reply. -6.52e+06. What is the difference between the Amount (in current US$) of Regional development banks in 1983 and the Amount (in current US$) of International Development Association in 1986?
Provide a short and direct response. -3.90e+06. What is the difference between the Amount (in current US$) in Regional development banks in 1983 and the Amount (in current US$) in Others in 1986?
Offer a very short reply. -1.80e+06. What is the difference between the Amount (in current US$) of International Development Association in 1983 and the Amount (in current US$) of Others in 1986?
Give a very brief answer. 4.73e+06. What is the difference between the Amount (in current US$) in Regional development banks in 1983 and the Amount (in current US$) in International Development Association in 1987?
Keep it short and to the point. -6.46e+06. What is the difference between the Amount (in current US$) in Regional development banks in 1983 and the Amount (in current US$) in Others in 1987?
Give a very brief answer. -3.80e+06. What is the difference between the Amount (in current US$) in International Development Association in 1983 and the Amount (in current US$) in Others in 1987?
Offer a very short reply. 2.72e+06. What is the difference between the Amount (in current US$) of Regional development banks in 1984 and the Amount (in current US$) of International Development Association in 1985?
Your response must be concise. -4.17e+06. What is the difference between the Amount (in current US$) of Regional development banks in 1984 and the Amount (in current US$) of Others in 1985?
Give a very brief answer. -4.52e+06. What is the difference between the Amount (in current US$) in International Development Association in 1984 and the Amount (in current US$) in Others in 1985?
Give a very brief answer. -2.79e+06. What is the difference between the Amount (in current US$) in Regional development banks in 1984 and the Amount (in current US$) in International Development Association in 1986?
Provide a succinct answer. -1.90e+06. What is the difference between the Amount (in current US$) in Regional development banks in 1984 and the Amount (in current US$) in Others in 1986?
Give a very brief answer. 2.02e+05. What is the difference between the Amount (in current US$) in International Development Association in 1984 and the Amount (in current US$) in Others in 1986?
Your answer should be compact. 1.93e+06. What is the difference between the Amount (in current US$) in Regional development banks in 1984 and the Amount (in current US$) in International Development Association in 1987?
Make the answer very short. -4.46e+06. What is the difference between the Amount (in current US$) of Regional development banks in 1984 and the Amount (in current US$) of Others in 1987?
Provide a succinct answer. -1.80e+06. What is the difference between the Amount (in current US$) of International Development Association in 1984 and the Amount (in current US$) of Others in 1987?
Your answer should be very brief. -7.80e+04. What is the difference between the Amount (in current US$) in Regional development banks in 1985 and the Amount (in current US$) in International Development Association in 1986?
Give a very brief answer. -1.37e+06. What is the difference between the Amount (in current US$) of Regional development banks in 1985 and the Amount (in current US$) of Others in 1986?
Ensure brevity in your answer.  7.40e+05. What is the difference between the Amount (in current US$) of International Development Association in 1985 and the Amount (in current US$) of Others in 1986?
Provide a succinct answer. 4.37e+06. What is the difference between the Amount (in current US$) in Regional development banks in 1985 and the Amount (in current US$) in International Development Association in 1987?
Provide a succinct answer. -3.93e+06. What is the difference between the Amount (in current US$) in Regional development banks in 1985 and the Amount (in current US$) in Others in 1987?
Provide a succinct answer. -1.27e+06. What is the difference between the Amount (in current US$) of International Development Association in 1985 and the Amount (in current US$) of Others in 1987?
Keep it short and to the point. 2.36e+06. What is the difference between the Amount (in current US$) in Regional development banks in 1986 and the Amount (in current US$) in International Development Association in 1987?
Make the answer very short. -2.70e+06. What is the difference between the Amount (in current US$) in Regional development banks in 1986 and the Amount (in current US$) in Others in 1987?
Provide a succinct answer. -3.90e+04. What is the average Amount (in current US$) in Regional development banks per year?
Your answer should be compact. 3.93e+06. What is the average Amount (in current US$) of International Monetary Fund per year?
Make the answer very short. 6.19e+05. What is the average Amount (in current US$) in International Development Association per year?
Provide a short and direct response. 5.82e+06. What is the average Amount (in current US$) of Others per year?
Your answer should be very brief. 3.40e+06. In the year 1978, what is the difference between the Amount (in current US$) of Regional development banks and Amount (in current US$) of International Monetary Fund?
Offer a terse response. 2.50e+04. In the year 1978, what is the difference between the Amount (in current US$) of Regional development banks and Amount (in current US$) of International Development Association?
Keep it short and to the point. -7.49e+05. In the year 1978, what is the difference between the Amount (in current US$) in Regional development banks and Amount (in current US$) in Others?
Your response must be concise. 8.61e+05. In the year 1978, what is the difference between the Amount (in current US$) of International Monetary Fund and Amount (in current US$) of International Development Association?
Your answer should be very brief. -7.74e+05. In the year 1978, what is the difference between the Amount (in current US$) in International Monetary Fund and Amount (in current US$) in Others?
Offer a very short reply. 8.36e+05. In the year 1978, what is the difference between the Amount (in current US$) in International Development Association and Amount (in current US$) in Others?
Your response must be concise. 1.61e+06. In the year 1979, what is the difference between the Amount (in current US$) in Regional development banks and Amount (in current US$) in International Monetary Fund?
Give a very brief answer. 2.76e+06. In the year 1979, what is the difference between the Amount (in current US$) of Regional development banks and Amount (in current US$) of International Development Association?
Ensure brevity in your answer.  2.12e+06. In the year 1979, what is the difference between the Amount (in current US$) of Regional development banks and Amount (in current US$) of Others?
Offer a terse response. 4.50e+06. In the year 1979, what is the difference between the Amount (in current US$) in International Monetary Fund and Amount (in current US$) in International Development Association?
Offer a terse response. -6.36e+05. In the year 1979, what is the difference between the Amount (in current US$) of International Monetary Fund and Amount (in current US$) of Others?
Make the answer very short. 1.74e+06. In the year 1979, what is the difference between the Amount (in current US$) of International Development Association and Amount (in current US$) of Others?
Your response must be concise. 2.38e+06. In the year 1980, what is the difference between the Amount (in current US$) in Regional development banks and Amount (in current US$) in International Monetary Fund?
Ensure brevity in your answer.  8.03e+05. In the year 1980, what is the difference between the Amount (in current US$) in Regional development banks and Amount (in current US$) in International Development Association?
Provide a succinct answer. -1.33e+06. In the year 1980, what is the difference between the Amount (in current US$) of Regional development banks and Amount (in current US$) of Others?
Ensure brevity in your answer.  2.34e+06. In the year 1980, what is the difference between the Amount (in current US$) of International Monetary Fund and Amount (in current US$) of International Development Association?
Offer a terse response. -2.13e+06. In the year 1980, what is the difference between the Amount (in current US$) of International Monetary Fund and Amount (in current US$) of Others?
Offer a very short reply. 1.54e+06. In the year 1980, what is the difference between the Amount (in current US$) of International Development Association and Amount (in current US$) of Others?
Give a very brief answer. 3.67e+06. In the year 1981, what is the difference between the Amount (in current US$) in Regional development banks and Amount (in current US$) in International Monetary Fund?
Give a very brief answer. 3.44e+06. In the year 1981, what is the difference between the Amount (in current US$) in Regional development banks and Amount (in current US$) in International Development Association?
Keep it short and to the point. -3.75e+06. In the year 1981, what is the difference between the Amount (in current US$) in Regional development banks and Amount (in current US$) in Others?
Give a very brief answer. 2.68e+06. In the year 1981, what is the difference between the Amount (in current US$) of International Monetary Fund and Amount (in current US$) of International Development Association?
Ensure brevity in your answer.  -7.19e+06. In the year 1981, what is the difference between the Amount (in current US$) of International Monetary Fund and Amount (in current US$) of Others?
Give a very brief answer. -7.69e+05. In the year 1981, what is the difference between the Amount (in current US$) of International Development Association and Amount (in current US$) of Others?
Ensure brevity in your answer.  6.42e+06. In the year 1983, what is the difference between the Amount (in current US$) of Regional development banks and Amount (in current US$) of International Development Association?
Make the answer very short. -6.53e+06. In the year 1983, what is the difference between the Amount (in current US$) of Regional development banks and Amount (in current US$) of Others?
Offer a very short reply. -3.32e+06. In the year 1983, what is the difference between the Amount (in current US$) of International Development Association and Amount (in current US$) of Others?
Your answer should be compact. 3.20e+06. In the year 1984, what is the difference between the Amount (in current US$) in Regional development banks and Amount (in current US$) in International Development Association?
Your answer should be compact. -1.73e+06. In the year 1984, what is the difference between the Amount (in current US$) of Regional development banks and Amount (in current US$) of Others?
Provide a succinct answer. -1.70e+06. In the year 1984, what is the difference between the Amount (in current US$) in International Development Association and Amount (in current US$) in Others?
Offer a very short reply. 2.80e+04. In the year 1985, what is the difference between the Amount (in current US$) of Regional development banks and Amount (in current US$) of International Development Association?
Your answer should be very brief. -3.63e+06. In the year 1985, what is the difference between the Amount (in current US$) in Regional development banks and Amount (in current US$) in Others?
Make the answer very short. -3.98e+06. In the year 1985, what is the difference between the Amount (in current US$) in International Development Association and Amount (in current US$) in Others?
Offer a terse response. -3.48e+05. In the year 1986, what is the difference between the Amount (in current US$) of Regional development banks and Amount (in current US$) of International Development Association?
Your response must be concise. -1.39e+05. In the year 1986, what is the difference between the Amount (in current US$) in Regional development banks and Amount (in current US$) in Others?
Offer a very short reply. 1.97e+06. In the year 1986, what is the difference between the Amount (in current US$) in International Development Association and Amount (in current US$) in Others?
Make the answer very short. 2.11e+06. In the year 1987, what is the difference between the Amount (in current US$) of Regional development banks and Amount (in current US$) of International Development Association?
Offer a very short reply. -1.31e+06. In the year 1987, what is the difference between the Amount (in current US$) of Regional development banks and Amount (in current US$) of Others?
Offer a terse response. 1.35e+06. In the year 1987, what is the difference between the Amount (in current US$) of International Development Association and Amount (in current US$) of Others?
Offer a very short reply. 2.66e+06. What is the ratio of the Amount (in current US$) of Regional development banks in 1978 to that in 1979?
Make the answer very short. 0.41. What is the ratio of the Amount (in current US$) in International Monetary Fund in 1978 to that in 1979?
Ensure brevity in your answer.  0.98. What is the ratio of the Amount (in current US$) of International Development Association in 1978 to that in 1979?
Your answer should be very brief. 1.04. What is the ratio of the Amount (in current US$) in Others in 1978 to that in 1979?
Give a very brief answer. 5.14. What is the ratio of the Amount (in current US$) in Regional development banks in 1978 to that in 1980?
Your answer should be very brief. 0.79. What is the ratio of the Amount (in current US$) of International Monetary Fund in 1978 to that in 1980?
Give a very brief answer. 1.16. What is the ratio of the Amount (in current US$) of International Development Association in 1978 to that in 1980?
Your answer should be very brief. 0.71. What is the ratio of the Amount (in current US$) in Others in 1978 to that in 1980?
Make the answer very short. 8.57. What is the ratio of the Amount (in current US$) of Regional development banks in 1978 to that in 1981?
Ensure brevity in your answer.  0.56. What is the ratio of the Amount (in current US$) in International Monetary Fund in 1978 to that in 1981?
Your response must be concise. 87.5. What is the ratio of the Amount (in current US$) in International Development Association in 1978 to that in 1981?
Keep it short and to the point. 0.37. What is the ratio of the Amount (in current US$) in Others in 1978 to that in 1981?
Offer a terse response. 1.38. What is the ratio of the Amount (in current US$) in Regional development banks in 1978 to that in 1983?
Keep it short and to the point. 1.05. What is the ratio of the Amount (in current US$) of International Development Association in 1978 to that in 1983?
Ensure brevity in your answer.  0.32. What is the ratio of the Amount (in current US$) in Others in 1978 to that in 1983?
Give a very brief answer. 0.21. What is the ratio of the Amount (in current US$) of Regional development banks in 1978 to that in 1984?
Offer a very short reply. 0.51. What is the ratio of the Amount (in current US$) in International Development Association in 1978 to that in 1984?
Provide a short and direct response. 0.48. What is the ratio of the Amount (in current US$) in Others in 1978 to that in 1984?
Keep it short and to the point. 0.2. What is the ratio of the Amount (in current US$) in Regional development banks in 1978 to that in 1985?
Provide a succinct answer. 0.44. What is the ratio of the Amount (in current US$) of International Development Association in 1978 to that in 1985?
Provide a succinct answer. 0.34. What is the ratio of the Amount (in current US$) in Others in 1978 to that in 1985?
Your answer should be compact. 0.13. What is the ratio of the Amount (in current US$) in Regional development banks in 1978 to that in 1986?
Your answer should be compact. 0.35. What is the ratio of the Amount (in current US$) of International Development Association in 1978 to that in 1986?
Your answer should be very brief. 0.47. What is the ratio of the Amount (in current US$) in Others in 1978 to that in 1986?
Your response must be concise. 0.3. What is the ratio of the Amount (in current US$) in Regional development banks in 1978 to that in 1987?
Offer a very short reply. 0.28. What is the ratio of the Amount (in current US$) in International Development Association in 1978 to that in 1987?
Keep it short and to the point. 0.32. What is the ratio of the Amount (in current US$) of Others in 1978 to that in 1987?
Provide a short and direct response. 0.19. What is the ratio of the Amount (in current US$) of Regional development banks in 1979 to that in 1980?
Provide a succinct answer. 1.91. What is the ratio of the Amount (in current US$) in International Monetary Fund in 1979 to that in 1980?
Offer a terse response. 1.17. What is the ratio of the Amount (in current US$) of International Development Association in 1979 to that in 1980?
Provide a succinct answer. 0.68. What is the ratio of the Amount (in current US$) in Others in 1979 to that in 1980?
Your answer should be very brief. 1.67. What is the ratio of the Amount (in current US$) in Regional development banks in 1979 to that in 1981?
Keep it short and to the point. 1.36. What is the ratio of the Amount (in current US$) of International Monetary Fund in 1979 to that in 1981?
Provide a short and direct response. 88.95. What is the ratio of the Amount (in current US$) in International Development Association in 1979 to that in 1981?
Provide a short and direct response. 0.36. What is the ratio of the Amount (in current US$) of Others in 1979 to that in 1981?
Give a very brief answer. 0.27. What is the ratio of the Amount (in current US$) in Regional development banks in 1979 to that in 1983?
Keep it short and to the point. 2.54. What is the ratio of the Amount (in current US$) of International Development Association in 1979 to that in 1983?
Give a very brief answer. 0.31. What is the ratio of the Amount (in current US$) in Others in 1979 to that in 1983?
Your response must be concise. 0.04. What is the ratio of the Amount (in current US$) in Regional development banks in 1979 to that in 1984?
Offer a terse response. 1.22. What is the ratio of the Amount (in current US$) in International Development Association in 1979 to that in 1984?
Ensure brevity in your answer.  0.46. What is the ratio of the Amount (in current US$) of Others in 1979 to that in 1984?
Offer a very short reply. 0.04. What is the ratio of the Amount (in current US$) of Regional development banks in 1979 to that in 1985?
Make the answer very short. 1.07. What is the ratio of the Amount (in current US$) of International Development Association in 1979 to that in 1985?
Your answer should be very brief. 0.32. What is the ratio of the Amount (in current US$) of Others in 1979 to that in 1985?
Keep it short and to the point. 0.03. What is the ratio of the Amount (in current US$) of Regional development banks in 1979 to that in 1986?
Offer a very short reply. 0.84. What is the ratio of the Amount (in current US$) in International Development Association in 1979 to that in 1986?
Your answer should be very brief. 0.45. What is the ratio of the Amount (in current US$) in Others in 1979 to that in 1986?
Make the answer very short. 0.06. What is the ratio of the Amount (in current US$) of Regional development banks in 1979 to that in 1987?
Provide a short and direct response. 0.67. What is the ratio of the Amount (in current US$) of International Development Association in 1979 to that in 1987?
Your response must be concise. 0.31. What is the ratio of the Amount (in current US$) in Others in 1979 to that in 1987?
Offer a very short reply. 0.04. What is the ratio of the Amount (in current US$) in Regional development banks in 1980 to that in 1981?
Your response must be concise. 0.71. What is the ratio of the Amount (in current US$) in International Monetary Fund in 1980 to that in 1981?
Offer a terse response. 75.73. What is the ratio of the Amount (in current US$) in International Development Association in 1980 to that in 1981?
Make the answer very short. 0.53. What is the ratio of the Amount (in current US$) in Others in 1980 to that in 1981?
Keep it short and to the point. 0.16. What is the ratio of the Amount (in current US$) of Regional development banks in 1980 to that in 1983?
Keep it short and to the point. 1.33. What is the ratio of the Amount (in current US$) in International Development Association in 1980 to that in 1983?
Offer a terse response. 0.45. What is the ratio of the Amount (in current US$) in Others in 1980 to that in 1983?
Offer a terse response. 0.02. What is the ratio of the Amount (in current US$) of Regional development banks in 1980 to that in 1984?
Make the answer very short. 0.64. What is the ratio of the Amount (in current US$) of International Development Association in 1980 to that in 1984?
Ensure brevity in your answer.  0.68. What is the ratio of the Amount (in current US$) in Others in 1980 to that in 1984?
Offer a very short reply. 0.02. What is the ratio of the Amount (in current US$) in Regional development banks in 1980 to that in 1985?
Your response must be concise. 0.56. What is the ratio of the Amount (in current US$) in International Development Association in 1980 to that in 1985?
Offer a very short reply. 0.47. What is the ratio of the Amount (in current US$) in Others in 1980 to that in 1985?
Keep it short and to the point. 0.02. What is the ratio of the Amount (in current US$) in Regional development banks in 1980 to that in 1986?
Provide a succinct answer. 0.44. What is the ratio of the Amount (in current US$) of International Development Association in 1980 to that in 1986?
Provide a short and direct response. 0.66. What is the ratio of the Amount (in current US$) of Others in 1980 to that in 1986?
Offer a terse response. 0.03. What is the ratio of the Amount (in current US$) of Regional development banks in 1980 to that in 1987?
Provide a short and direct response. 0.35. What is the ratio of the Amount (in current US$) in International Development Association in 1980 to that in 1987?
Provide a short and direct response. 0.46. What is the ratio of the Amount (in current US$) of Others in 1980 to that in 1987?
Provide a short and direct response. 0.02. What is the ratio of the Amount (in current US$) in Regional development banks in 1981 to that in 1983?
Your response must be concise. 1.87. What is the ratio of the Amount (in current US$) in International Development Association in 1981 to that in 1983?
Your response must be concise. 0.86. What is the ratio of the Amount (in current US$) in Others in 1981 to that in 1983?
Offer a very short reply. 0.15. What is the ratio of the Amount (in current US$) in Regional development banks in 1981 to that in 1984?
Ensure brevity in your answer.  0.9. What is the ratio of the Amount (in current US$) in International Development Association in 1981 to that in 1984?
Your response must be concise. 1.29. What is the ratio of the Amount (in current US$) of Others in 1981 to that in 1984?
Your answer should be very brief. 0.14. What is the ratio of the Amount (in current US$) in Regional development banks in 1981 to that in 1985?
Provide a short and direct response. 0.79. What is the ratio of the Amount (in current US$) of International Development Association in 1981 to that in 1985?
Provide a short and direct response. 0.9. What is the ratio of the Amount (in current US$) in Others in 1981 to that in 1985?
Offer a very short reply. 0.09. What is the ratio of the Amount (in current US$) in Regional development banks in 1981 to that in 1986?
Keep it short and to the point. 0.62. What is the ratio of the Amount (in current US$) in International Development Association in 1981 to that in 1986?
Provide a succinct answer. 1.25. What is the ratio of the Amount (in current US$) in Others in 1981 to that in 1986?
Offer a terse response. 0.22. What is the ratio of the Amount (in current US$) in Regional development banks in 1981 to that in 1987?
Ensure brevity in your answer.  0.49. What is the ratio of the Amount (in current US$) of International Development Association in 1981 to that in 1987?
Your response must be concise. 0.87. What is the ratio of the Amount (in current US$) in Others in 1981 to that in 1987?
Offer a terse response. 0.14. What is the ratio of the Amount (in current US$) in Regional development banks in 1983 to that in 1984?
Provide a succinct answer. 0.48. What is the ratio of the Amount (in current US$) in International Development Association in 1983 to that in 1984?
Keep it short and to the point. 1.5. What is the ratio of the Amount (in current US$) of Others in 1983 to that in 1984?
Ensure brevity in your answer.  0.93. What is the ratio of the Amount (in current US$) of Regional development banks in 1983 to that in 1985?
Give a very brief answer. 0.42. What is the ratio of the Amount (in current US$) of International Development Association in 1983 to that in 1985?
Ensure brevity in your answer.  1.04. What is the ratio of the Amount (in current US$) of Others in 1983 to that in 1985?
Provide a succinct answer. 0.62. What is the ratio of the Amount (in current US$) of Regional development banks in 1983 to that in 1986?
Keep it short and to the point. 0.33. What is the ratio of the Amount (in current US$) of International Development Association in 1983 to that in 1986?
Give a very brief answer. 1.46. What is the ratio of the Amount (in current US$) in Others in 1983 to that in 1986?
Your response must be concise. 1.42. What is the ratio of the Amount (in current US$) in Regional development banks in 1983 to that in 1987?
Provide a succinct answer. 0.26. What is the ratio of the Amount (in current US$) in International Development Association in 1983 to that in 1987?
Provide a short and direct response. 1.01. What is the ratio of the Amount (in current US$) of Others in 1983 to that in 1987?
Give a very brief answer. 0.92. What is the ratio of the Amount (in current US$) in Regional development banks in 1984 to that in 1985?
Ensure brevity in your answer.  0.88. What is the ratio of the Amount (in current US$) in International Development Association in 1984 to that in 1985?
Your answer should be compact. 0.7. What is the ratio of the Amount (in current US$) in Others in 1984 to that in 1985?
Give a very brief answer. 0.66. What is the ratio of the Amount (in current US$) of Regional development banks in 1984 to that in 1986?
Provide a short and direct response. 0.69. What is the ratio of the Amount (in current US$) of International Development Association in 1984 to that in 1986?
Ensure brevity in your answer.  0.97. What is the ratio of the Amount (in current US$) of Others in 1984 to that in 1986?
Keep it short and to the point. 1.52. What is the ratio of the Amount (in current US$) in Regional development banks in 1984 to that in 1987?
Make the answer very short. 0.55. What is the ratio of the Amount (in current US$) in International Development Association in 1984 to that in 1987?
Your answer should be compact. 0.67. What is the ratio of the Amount (in current US$) of Others in 1984 to that in 1987?
Keep it short and to the point. 0.98. What is the ratio of the Amount (in current US$) in Regional development banks in 1985 to that in 1986?
Keep it short and to the point. 0.78. What is the ratio of the Amount (in current US$) of International Development Association in 1985 to that in 1986?
Keep it short and to the point. 1.39. What is the ratio of the Amount (in current US$) of Others in 1985 to that in 1986?
Offer a very short reply. 2.29. What is the ratio of the Amount (in current US$) in Regional development banks in 1985 to that in 1987?
Give a very brief answer. 0.63. What is the ratio of the Amount (in current US$) in International Development Association in 1985 to that in 1987?
Provide a short and direct response. 0.96. What is the ratio of the Amount (in current US$) in Others in 1985 to that in 1987?
Ensure brevity in your answer.  1.48. What is the ratio of the Amount (in current US$) in Regional development banks in 1986 to that in 1987?
Make the answer very short. 0.8. What is the ratio of the Amount (in current US$) in International Development Association in 1986 to that in 1987?
Offer a terse response. 0.69. What is the ratio of the Amount (in current US$) of Others in 1986 to that in 1987?
Your response must be concise. 0.65. What is the difference between the highest and the second highest Amount (in current US$) of Regional development banks?
Your response must be concise. 1.39e+06. What is the difference between the highest and the second highest Amount (in current US$) of International Monetary Fund?
Offer a terse response. 3.20e+04. What is the difference between the highest and the second highest Amount (in current US$) in International Development Association?
Your response must be concise. 6.30e+04. What is the difference between the highest and the second highest Amount (in current US$) in Others?
Provide a succinct answer. 2.71e+06. What is the difference between the highest and the lowest Amount (in current US$) in Regional development banks?
Offer a terse response. 5.16e+06. What is the difference between the highest and the lowest Amount (in current US$) in International Monetary Fund?
Your answer should be compact. 1.96e+06. What is the difference between the highest and the lowest Amount (in current US$) in International Development Association?
Make the answer very short. 5.79e+06. What is the difference between the highest and the lowest Amount (in current US$) of Others?
Give a very brief answer. 8.24e+06. 